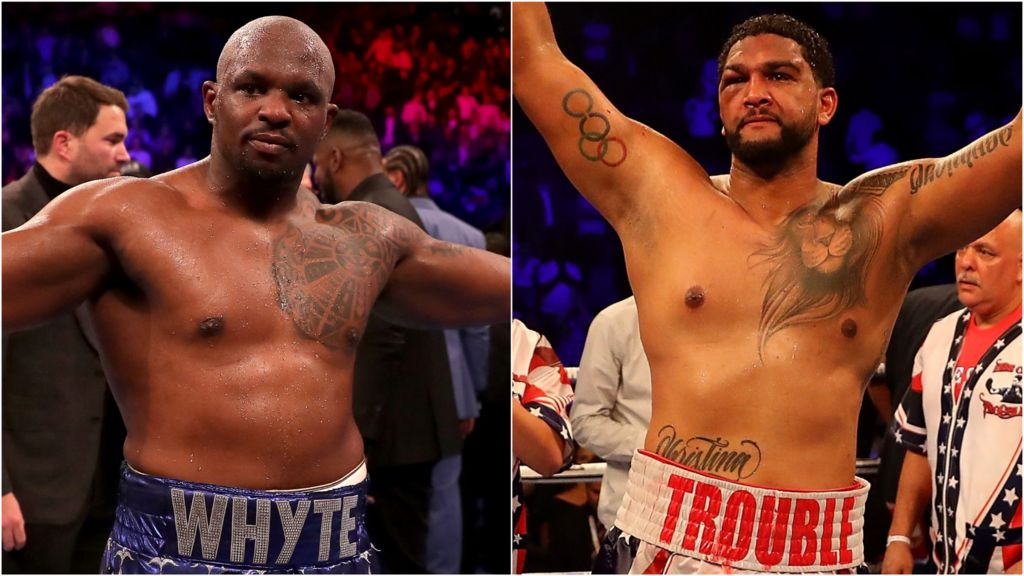Considering the intense physical training boxers undergo, describe a typical day in their life. A typical day in the life of a professional boxer is an intense blend of physical training, strategic planning, and mental fortitude. Their day generally begins before dawn with a session of roadwork, running several miles to build endurance and stamina. Following breakfast, the morning workout usually includes strength and conditioning exercises, such as weightlifting, calisthenics, and plyometric drills, designed to enhance power and agility. Afternoons are often dedicated to technical training, including sparring sessions, mitt work with a coach, and practicing various punches and defensive maneuvers. Nutrition and recovery play crucial roles, with meals meticulously planned to fuel their bodies optimally and recovery tactics like ice baths, massages, and physiotherapy employed to mitigate injuries and ensure peak physical condition. The day typically ends with reviewing fight footage to devise strategies, followed by a final light workout or stretching routine to maintain flexibility and balance. This rigorous regimen is not just about physical ability but also about mental toughness, imbibing discipline, focus, and resilience integral to their success in the ring. A day in the life of a boxer starts early, usually with a heart-pumping run to build cardiovascular fitness. Breakfast follows, consisting of a balanced meal rich in protein and nutrients. The boxer then heads to the gym for a grueling session of strength training, focusing on building muscle and enhancing overall power. After a brief rest, the boxer engages in boxing-specific training, including precision drills, hitting the bags, and sparring with partners to hone skills and techniques. Throughout the day, the boxer remains hydrated and consumes small meals to maintain energy levels. Recovery is vital — techniques like stretching, massages, and ice baths are utilized to reduce injury risks. The evening often includes reviewing match footage to analyze performance and plan future strategies. The day winds down with a lighter workout and relaxation activities to ensure mental well-being, underscoring the balanced yet demanding lifestyle required to compete at the highest levels. 